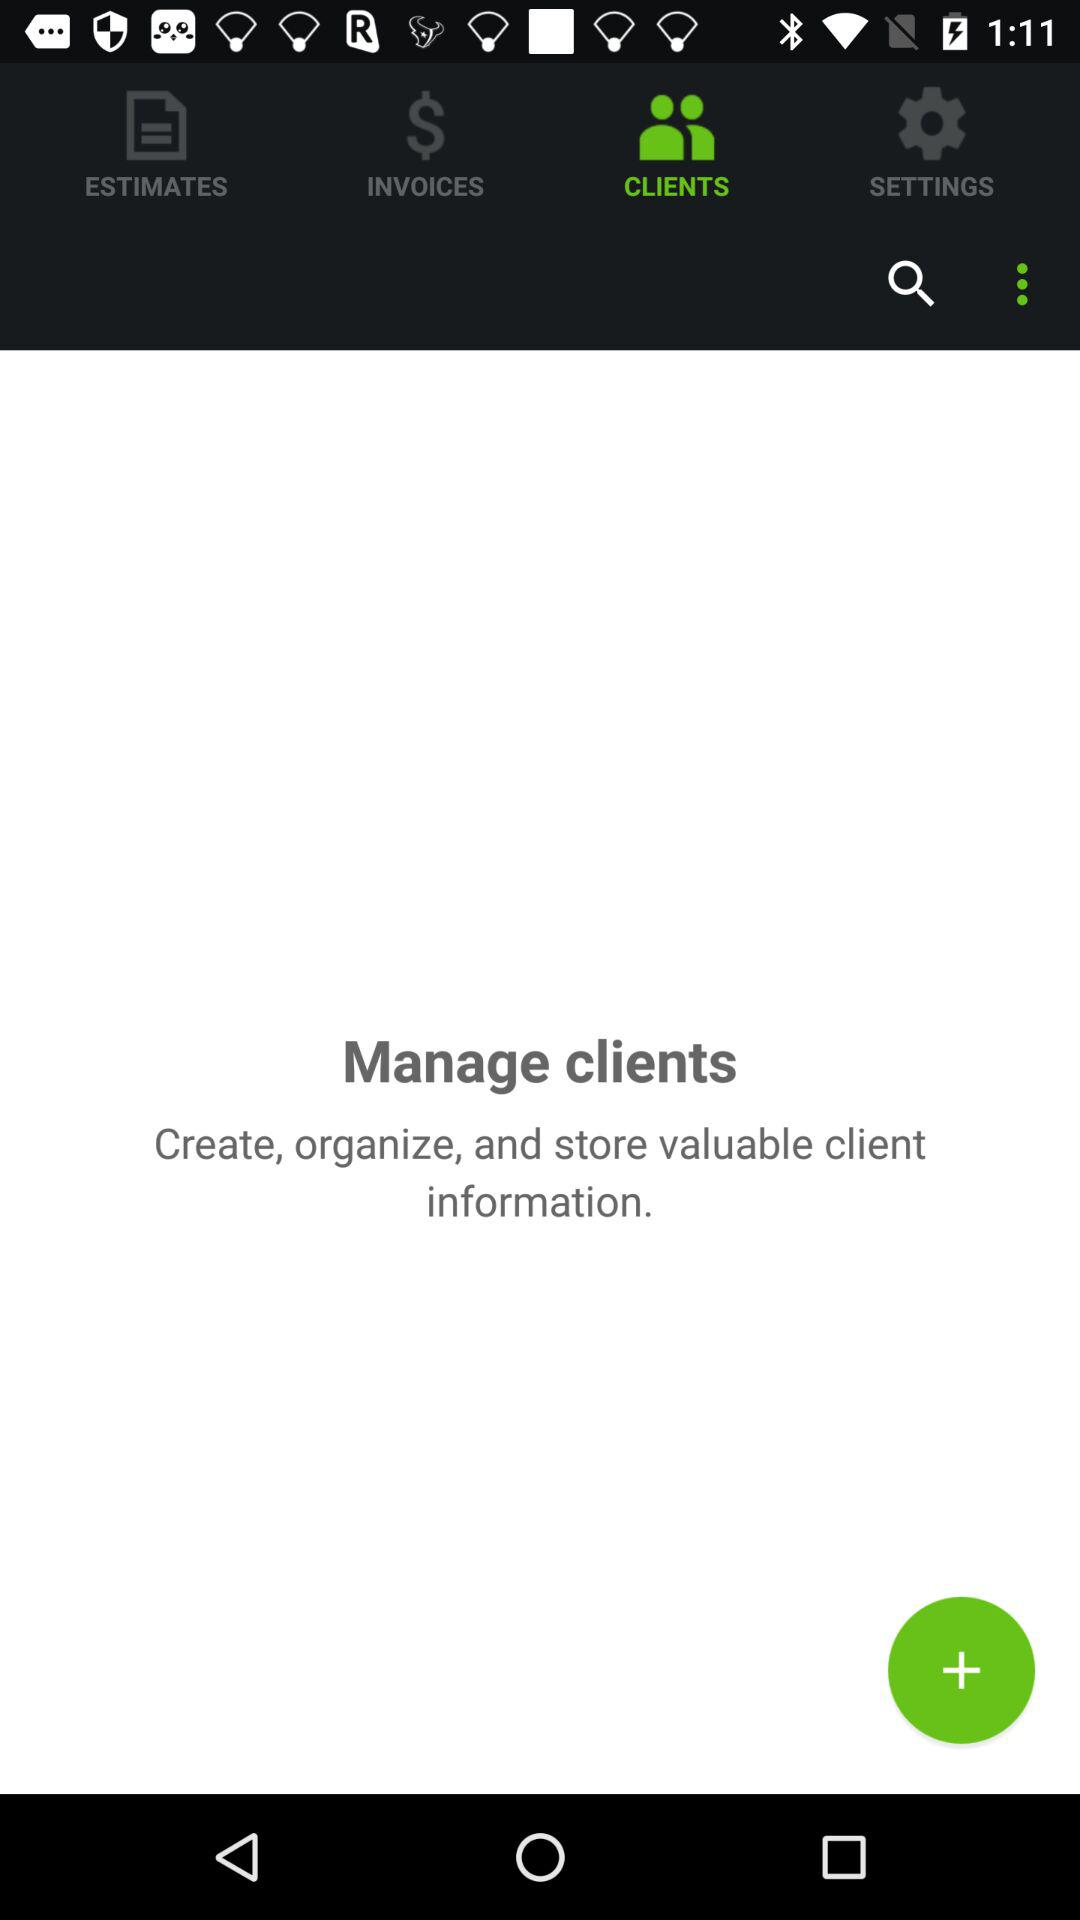Which tab is selected? The selected tab is "CLIENTS". 